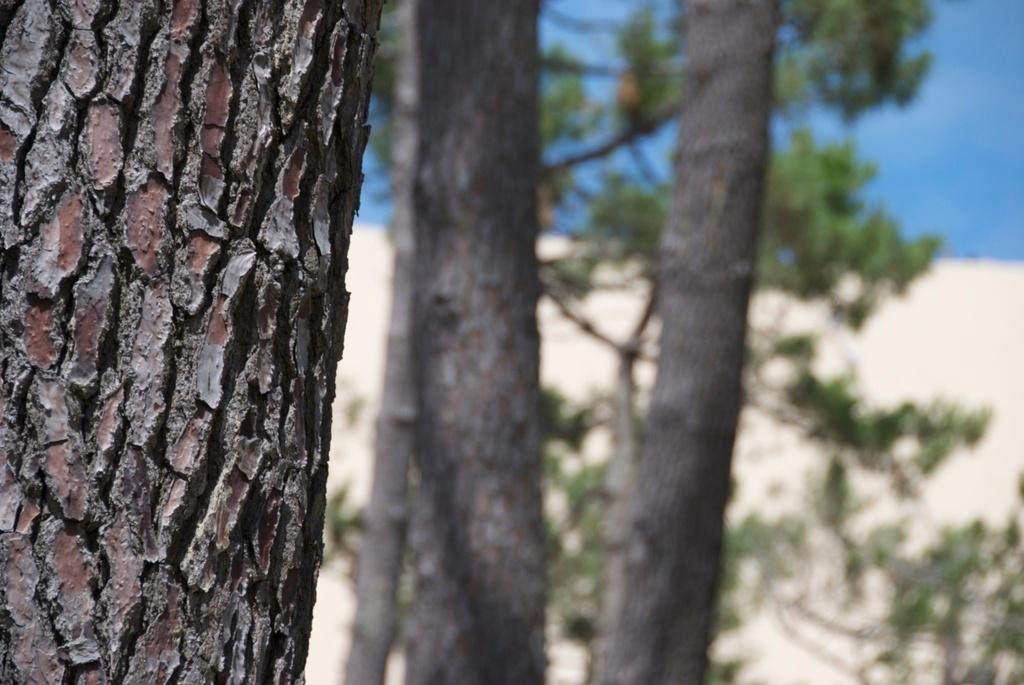What object is the main focus of the image? There is a trunk in the image. What can be seen in the background of the image? There are trees in the background of the image. What is the color of the trees? The trees are green. What is the color of the sky in the image? The sky is blue. How many geese are flying over the trunk in the image? There are no geese present in the image. Is there a crown on top of the trunk in the image? There is no crown present in the image. 